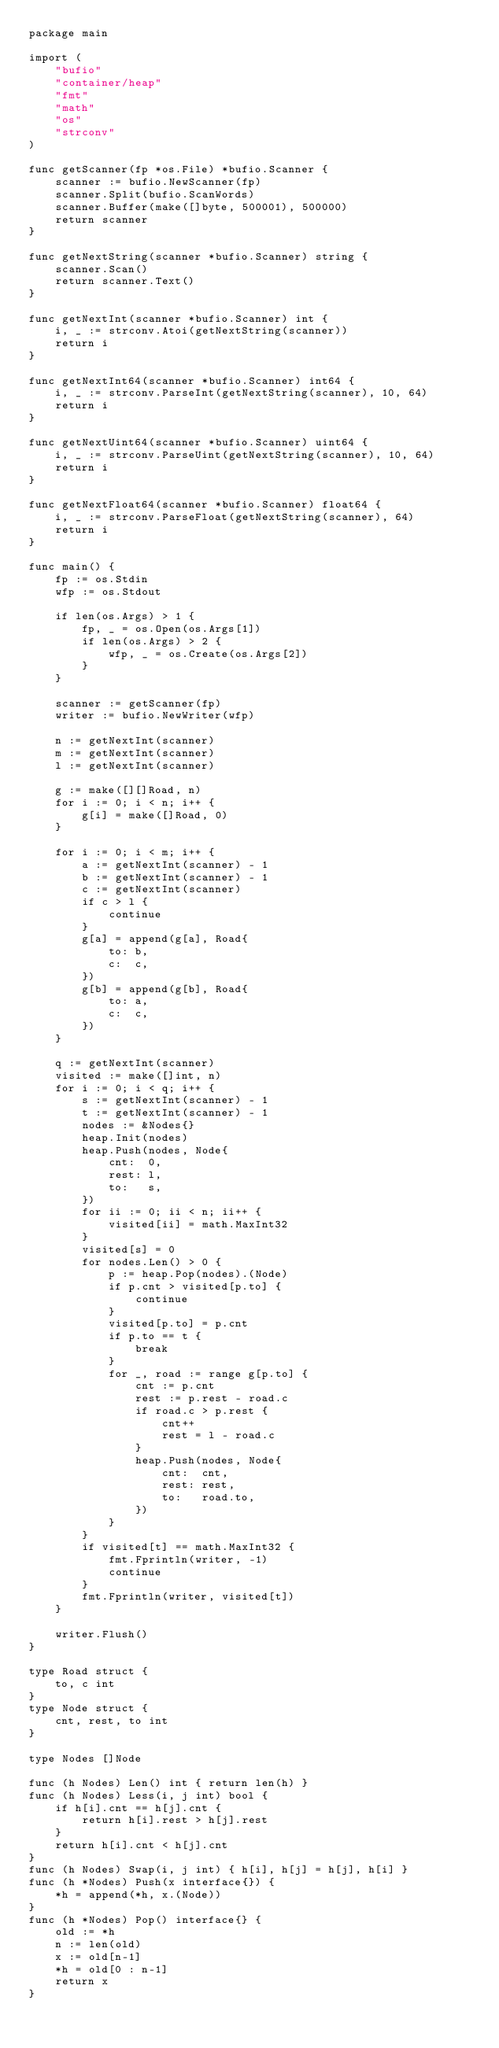<code> <loc_0><loc_0><loc_500><loc_500><_Go_>package main

import (
	"bufio"
	"container/heap"
	"fmt"
	"math"
	"os"
	"strconv"
)

func getScanner(fp *os.File) *bufio.Scanner {
	scanner := bufio.NewScanner(fp)
	scanner.Split(bufio.ScanWords)
	scanner.Buffer(make([]byte, 500001), 500000)
	return scanner
}

func getNextString(scanner *bufio.Scanner) string {
	scanner.Scan()
	return scanner.Text()
}

func getNextInt(scanner *bufio.Scanner) int {
	i, _ := strconv.Atoi(getNextString(scanner))
	return i
}

func getNextInt64(scanner *bufio.Scanner) int64 {
	i, _ := strconv.ParseInt(getNextString(scanner), 10, 64)
	return i
}

func getNextUint64(scanner *bufio.Scanner) uint64 {
	i, _ := strconv.ParseUint(getNextString(scanner), 10, 64)
	return i
}

func getNextFloat64(scanner *bufio.Scanner) float64 {
	i, _ := strconv.ParseFloat(getNextString(scanner), 64)
	return i
}

func main() {
	fp := os.Stdin
	wfp := os.Stdout

	if len(os.Args) > 1 {
		fp, _ = os.Open(os.Args[1])
		if len(os.Args) > 2 {
			wfp, _ = os.Create(os.Args[2])
		}
	}

	scanner := getScanner(fp)
	writer := bufio.NewWriter(wfp)

	n := getNextInt(scanner)
	m := getNextInt(scanner)
	l := getNextInt(scanner)

	g := make([][]Road, n)
	for i := 0; i < n; i++ {
		g[i] = make([]Road, 0)
	}

	for i := 0; i < m; i++ {
		a := getNextInt(scanner) - 1
		b := getNextInt(scanner) - 1
		c := getNextInt(scanner)
		if c > l {
			continue
		}
		g[a] = append(g[a], Road{
			to: b,
			c:  c,
		})
		g[b] = append(g[b], Road{
			to: a,
			c:  c,
		})
	}

	q := getNextInt(scanner)
	visited := make([]int, n)
	for i := 0; i < q; i++ {
		s := getNextInt(scanner) - 1
		t := getNextInt(scanner) - 1
		nodes := &Nodes{}
		heap.Init(nodes)
		heap.Push(nodes, Node{
			cnt:  0,
			rest: l,
			to:   s,
		})
		for ii := 0; ii < n; ii++ {
			visited[ii] = math.MaxInt32
		}
		visited[s] = 0
		for nodes.Len() > 0 {
			p := heap.Pop(nodes).(Node)
			if p.cnt > visited[p.to] {
				continue
			}
			visited[p.to] = p.cnt
			if p.to == t {
				break
			}
			for _, road := range g[p.to] {
				cnt := p.cnt
				rest := p.rest - road.c
				if road.c > p.rest {
					cnt++
					rest = l - road.c
				}
				heap.Push(nodes, Node{
					cnt:  cnt,
					rest: rest,
					to:   road.to,
				})
			}
		}
		if visited[t] == math.MaxInt32 {
			fmt.Fprintln(writer, -1)
			continue
		}
		fmt.Fprintln(writer, visited[t])
	}

	writer.Flush()
}

type Road struct {
	to, c int
}
type Node struct {
	cnt, rest, to int
}

type Nodes []Node

func (h Nodes) Len() int { return len(h) }
func (h Nodes) Less(i, j int) bool {
	if h[i].cnt == h[j].cnt {
		return h[i].rest > h[j].rest
	}
	return h[i].cnt < h[j].cnt
}
func (h Nodes) Swap(i, j int) { h[i], h[j] = h[j], h[i] }
func (h *Nodes) Push(x interface{}) {
	*h = append(*h, x.(Node))
}
func (h *Nodes) Pop() interface{} {
	old := *h
	n := len(old)
	x := old[n-1]
	*h = old[0 : n-1]
	return x
}
</code> 